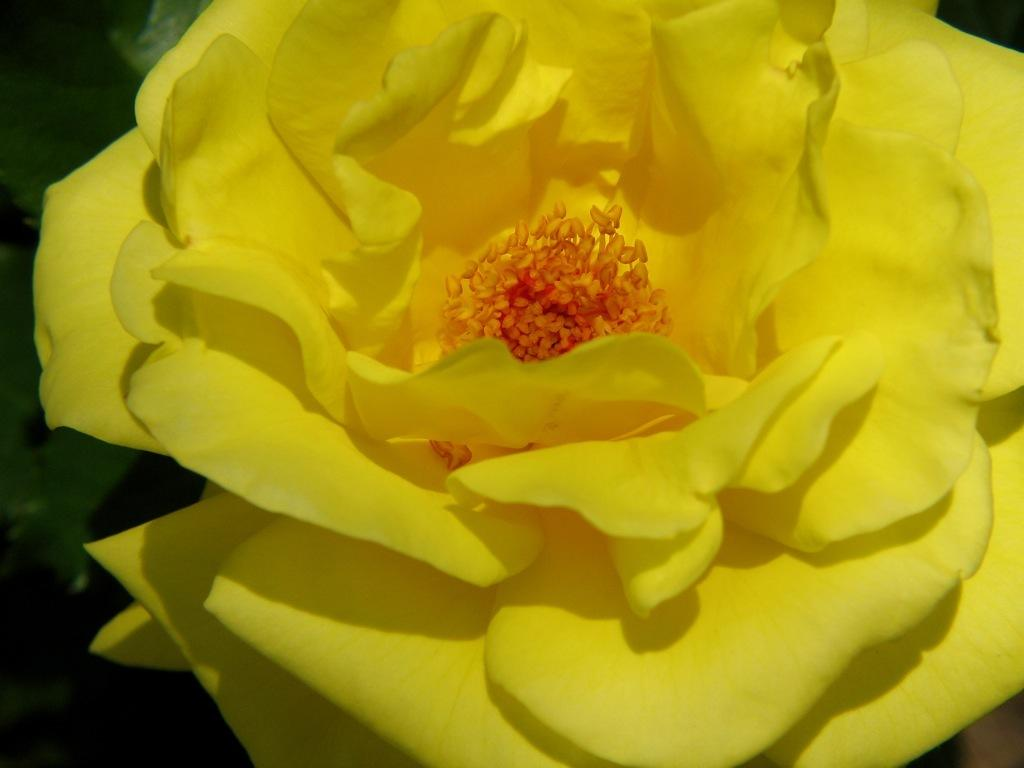What type of flower is present in the image? There is a yellow flower in the image. What type of meat is being cooked in the tub in the image? There is no tub, meat, or cooking activity present in the image; it only features a yellow flower. 